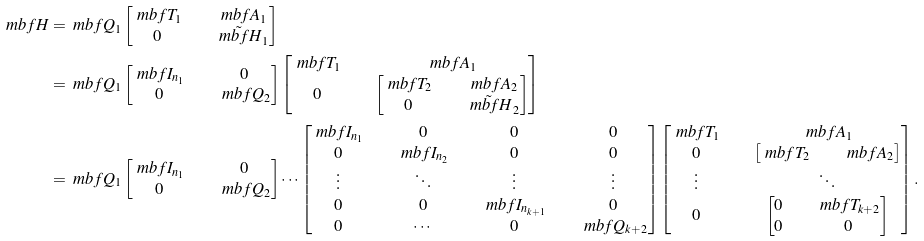<formula> <loc_0><loc_0><loc_500><loc_500>\ m b f { H } & = \ m b f { Q } _ { 1 } \begin{bmatrix} \ m b f { T } _ { 1 } & & \ m b f { A } _ { 1 } \\ 0 & & \tilde { \ m b f { H } } _ { 1 } \end{bmatrix} \\ & = \ m b f { Q } _ { 1 } \begin{bmatrix} \ m b f { I } _ { n _ { 1 } } & & 0 \\ 0 & & \ m b f { Q } _ { 2 } \end{bmatrix} \begin{bmatrix} \ m b f { T } _ { 1 } & & \ m b f { A } _ { 1 } \\ 0 & & \begin{bmatrix} \ m b f { T } _ { 2 } & & \ m b f { A } _ { 2 } \\ 0 & & \tilde { \ m b f { H } } _ { 2 } \end{bmatrix} \end{bmatrix} \\ & = \ m b f { Q } _ { 1 } \begin{bmatrix} \ m b f { I } _ { n _ { 1 } } & & 0 \\ 0 & & \ m b f { Q } _ { 2 } \end{bmatrix} \cdots \begin{bmatrix} \ m b f { I } _ { n _ { 1 } } & & 0 & & 0 & & 0 \\ 0 & & \ m b f { I } _ { n _ { 2 } } & & 0 & & 0 \\ \vdots & & \ddots & & \vdots & & \vdots \\ 0 & & 0 & & \ m b f { I } _ { n _ { k + 1 } } & & 0 \\ 0 & & \cdots & & 0 & & \ m b f { Q } _ { k + 2 } \end{bmatrix} \begin{bmatrix} \ m b f { T } _ { 1 } & & \ m b f { A } _ { 1 } \\ 0 & & \begin{bmatrix} \ m b f { T } _ { 2 } & & \ m b f { A } _ { 2 } \end{bmatrix} \\ \vdots & & \ddots \\ 0 & & \begin{bmatrix} 0 & & \ m b f { T } _ { k + 2 } \\ 0 & & 0 \end{bmatrix} \end{bmatrix} .</formula> 